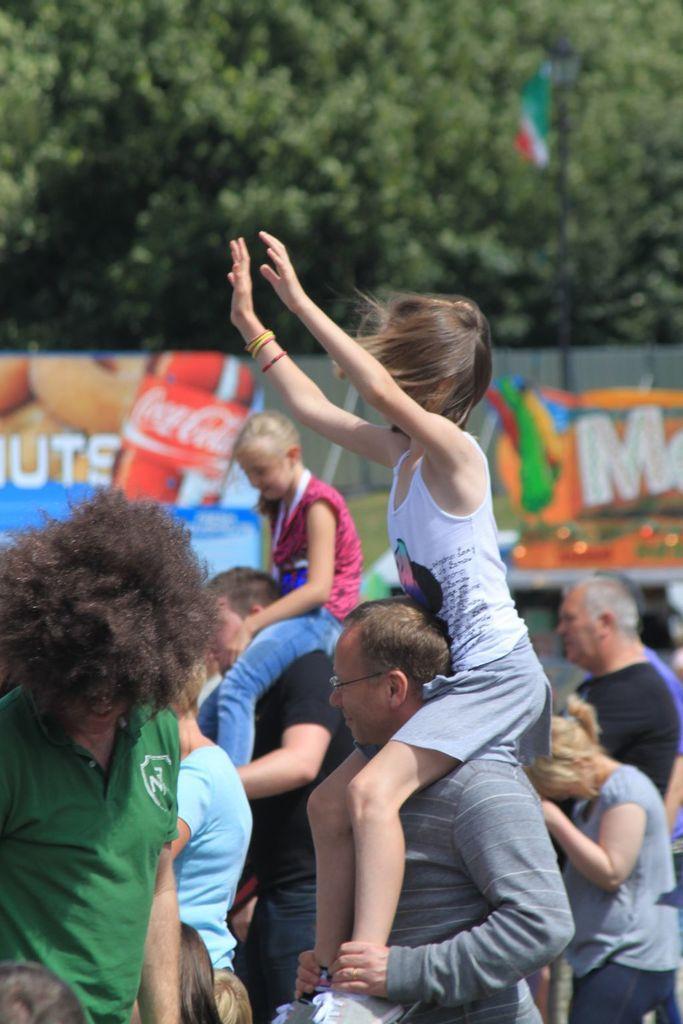Please provide a concise description of this image. In this image we can see many people. In the back we can see banners. Also there is a flag with a pole. In the background there are trees. 